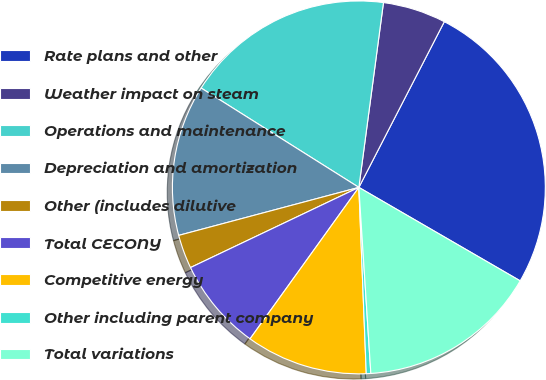Convert chart to OTSL. <chart><loc_0><loc_0><loc_500><loc_500><pie_chart><fcel>Rate plans and other<fcel>Weather impact on steam<fcel>Operations and maintenance<fcel>Depreciation and amortization<fcel>Other (includes dilutive<fcel>Total CECONY<fcel>Competitive energy<fcel>Other including parent company<fcel>Total variations<nl><fcel>25.78%<fcel>5.47%<fcel>18.16%<fcel>13.09%<fcel>2.93%<fcel>8.01%<fcel>10.55%<fcel>0.39%<fcel>15.62%<nl></chart> 